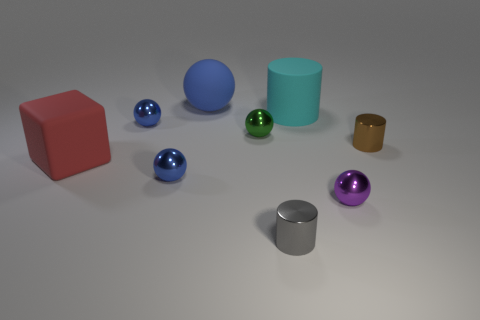Subtract all blue balls. How many were subtracted if there are1blue balls left? 2 Subtract all tiny purple metallic balls. How many balls are left? 4 Subtract all gray cylinders. How many cylinders are left? 2 Subtract 2 cylinders. How many cylinders are left? 1 Subtract all cylinders. How many objects are left? 6 Subtract all big metal objects. Subtract all tiny blue shiny balls. How many objects are left? 7 Add 6 big spheres. How many big spheres are left? 7 Add 7 matte cubes. How many matte cubes exist? 8 Subtract 0 yellow balls. How many objects are left? 9 Subtract all purple cylinders. Subtract all purple blocks. How many cylinders are left? 3 